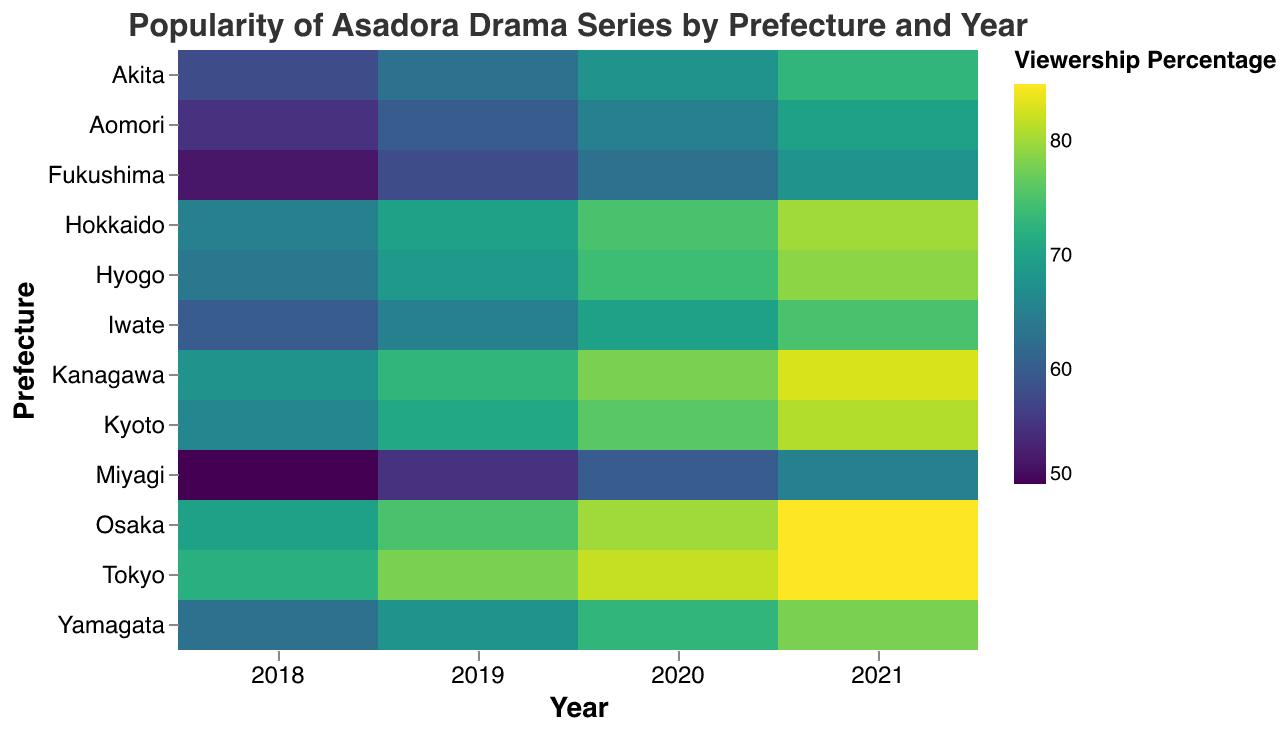Which prefecture had the highest viewership percentage in 2021? Locate the year 2021 on the x-axis and scan vertically through the colors for each prefecture, noting that darker colors indicate higher viewership percentages. Tokyo and Osaka both clearly show the darkest colors in 2021, representing the highest viewership percentages.
Answer: Tokyo and Osaka How did the viewership percentage in Aomori change from 2018 to 2021? Locate Aomori on the y-axis and follow its row horizontally across the years 2018 to 2021. The viewership percentages are 55 (2018), 60 (2019), 65 (2020), and 70 (2021). The percentages show an increasing trend.
Answer: Increased Which year had the highest overall viewership percentage across all prefectures? Examine each column (representing a year) by observing the colors. The darker the colors in a column, the higher overall viewership for that year. The year 2021 has the darkest shades across most prefectures, indicating the highest overall viewership percentage.
Answer: 2021 What was the viewership percentage for Tokyo in 2019? Find Tokyo on the y-axis and move horizontally to the year 2019. The cell intersection gives the viewership percentage.
Answer: 78 Compare the viewership percentages between Hokkaido and Hyogo in 2020. Which one is higher? Locate Hokkaido and Hyogo on the y-axis and follow their respective rows to 2020. The viewership percentages for Hokkaido and Hyogo are 75 and 74, respectively.
Answer: Hokkaido Identify the prefecture with the lowest viewership percentage in 2018. Locate the year 2018 on the x-axis, and scan vertically observing the colors; the lightest color indicates the lowest viewership percentage. Miyagi has the lightest color, marking it as the prefecture with the lowest percentage.
Answer: Miyagi What is the average viewership percentage for Kyoto from 2018 to 2021? Find Kyoto on the y-axis, and note the viewership percentages for the years 2018 to 2021: 66, 71, 76, and 81. Calculate the average by adding these values and dividing by 4. (66 + 71 + 76 + 81) / 4 = 73.5
Answer: 73.5 Which prefecture had the greatest increase in viewership percentage from 2018 to 2021? Track each prefecture’s viewership percentages from 2018 to 2021 and calculate the differences. Hokkaido’s viewership increased from 65 in 2018 to 80 in 2021, which is a 15% increase, while others increased by smaller margins.
Answer: Hokkaido Was there any prefecture where the viewership stayed the same for any two consecutive years? If yes, identify the prefecture and the years. Compare the viewership percentages of each prefecture between consecutive years (2018-2019, 2019-2020, 2020-2021). None of the prefectures maintain the same viewership percentage for any two consecutive years.
Answer: No 